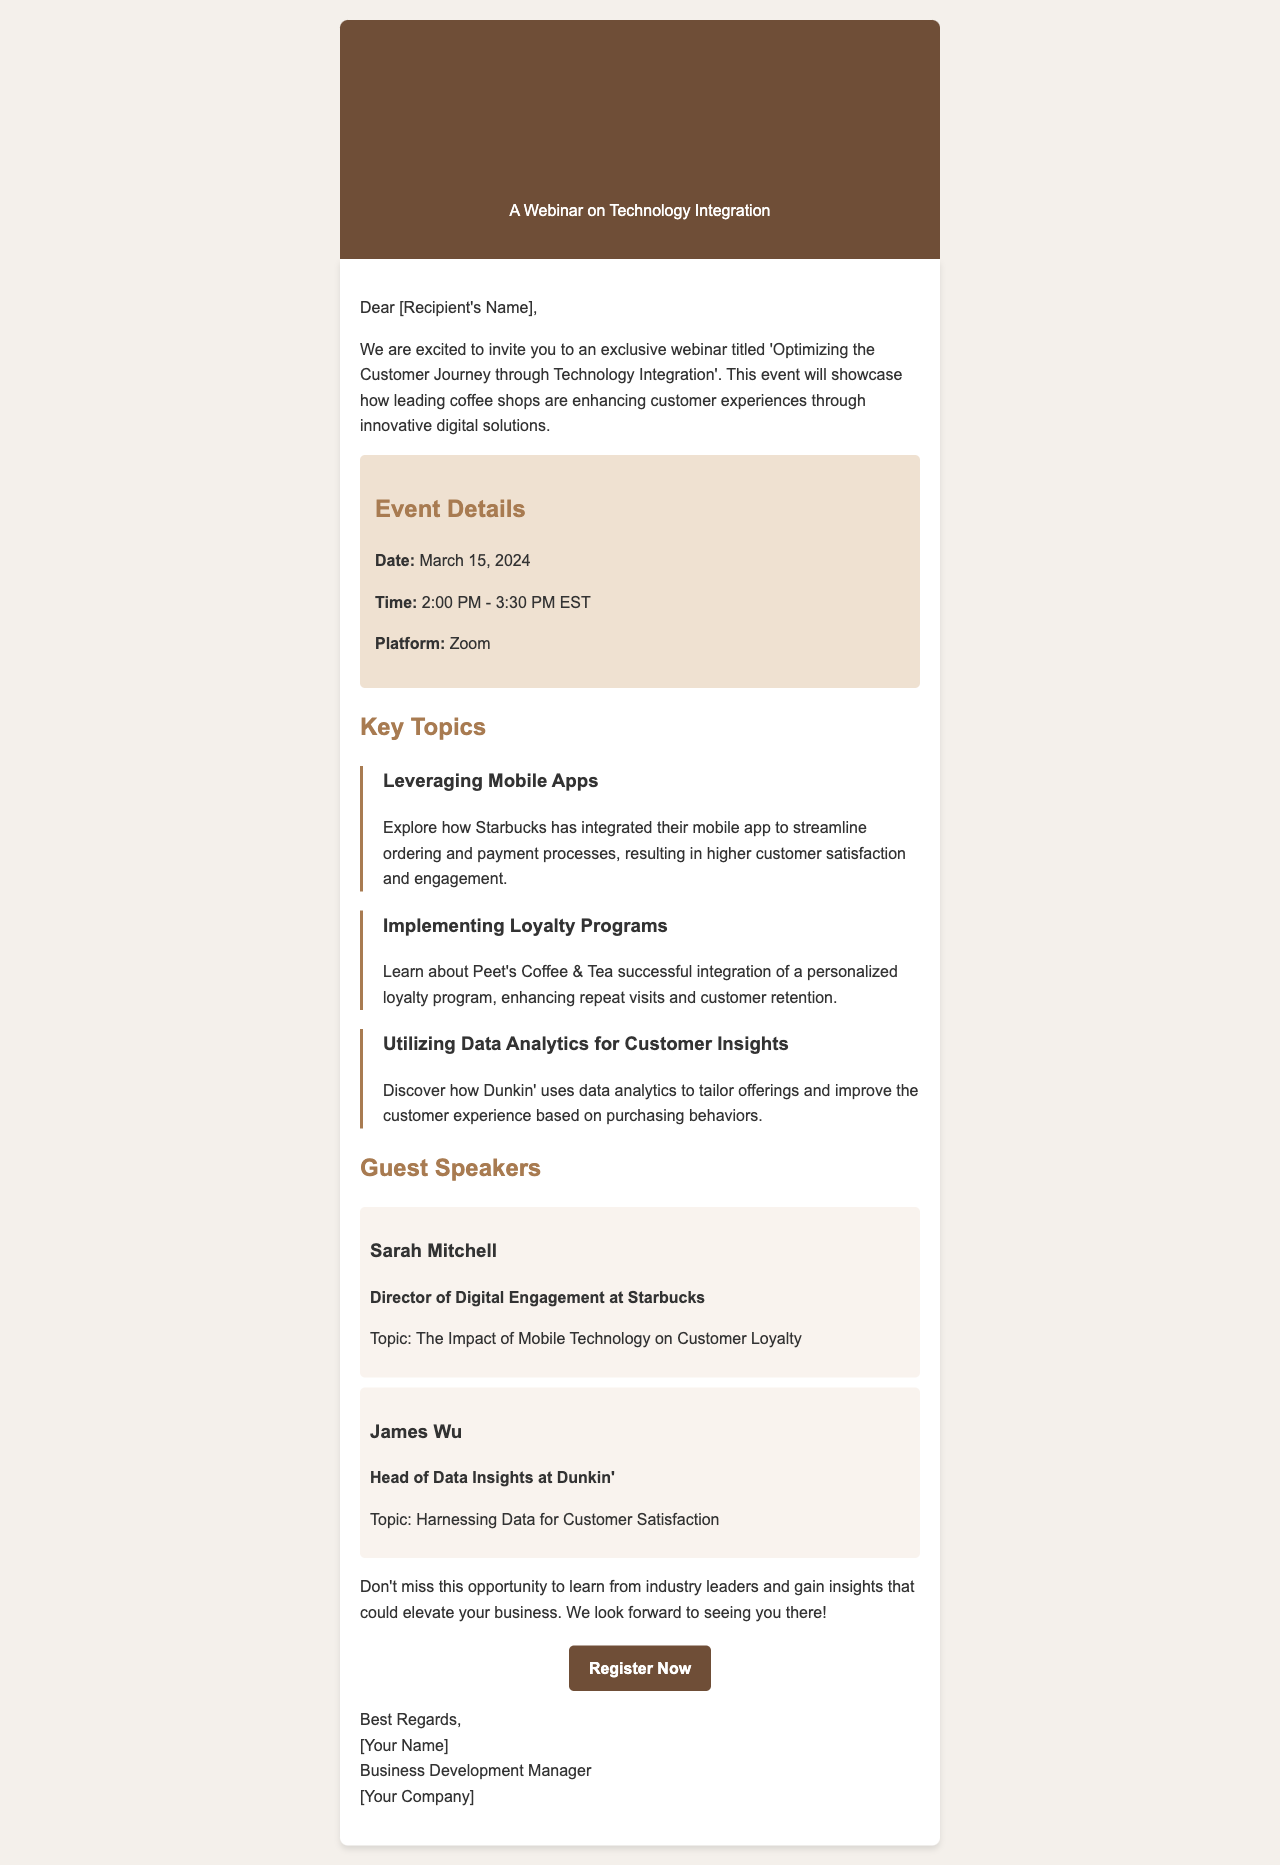What is the title of the webinar? The title of the webinar is stated at the beginning of the document as 'Optimizing the Customer Journey through Technology Integration'.
Answer: Optimizing the Customer Journey through Technology Integration When is the webinar scheduled? The date of the webinar is mentioned in the event details section as March 15, 2024.
Answer: March 15, 2024 What time does the webinar start? The start time of the webinar is provided in the event details, specified as 2:00 PM EST.
Answer: 2:00 PM Who is one of the guest speakers? The document lists Sarah Mitchell as one of the guest speakers along with her title.
Answer: Sarah Mitchell What topic will Sarah Mitchell discuss? The document mentions the topic for Sarah Mitchell as 'The Impact of Mobile Technology on Customer Loyalty'.
Answer: The Impact of Mobile Technology on Customer Loyalty Which coffee shop is associated with the loyalty programs topic? The document specifically mentions Peet's Coffee & Tea in relation to the personalized loyalty program topic.
Answer: Peet's Coffee & Tea What is the registration platform for the webinar? The platform where the webinar will take place is noted in the event details and is Zoom.
Answer: Zoom What should attendees do to join the webinar? Attendees are prompted to click a link to register for the webinar as indicated in the call to action section.
Answer: Register Now 